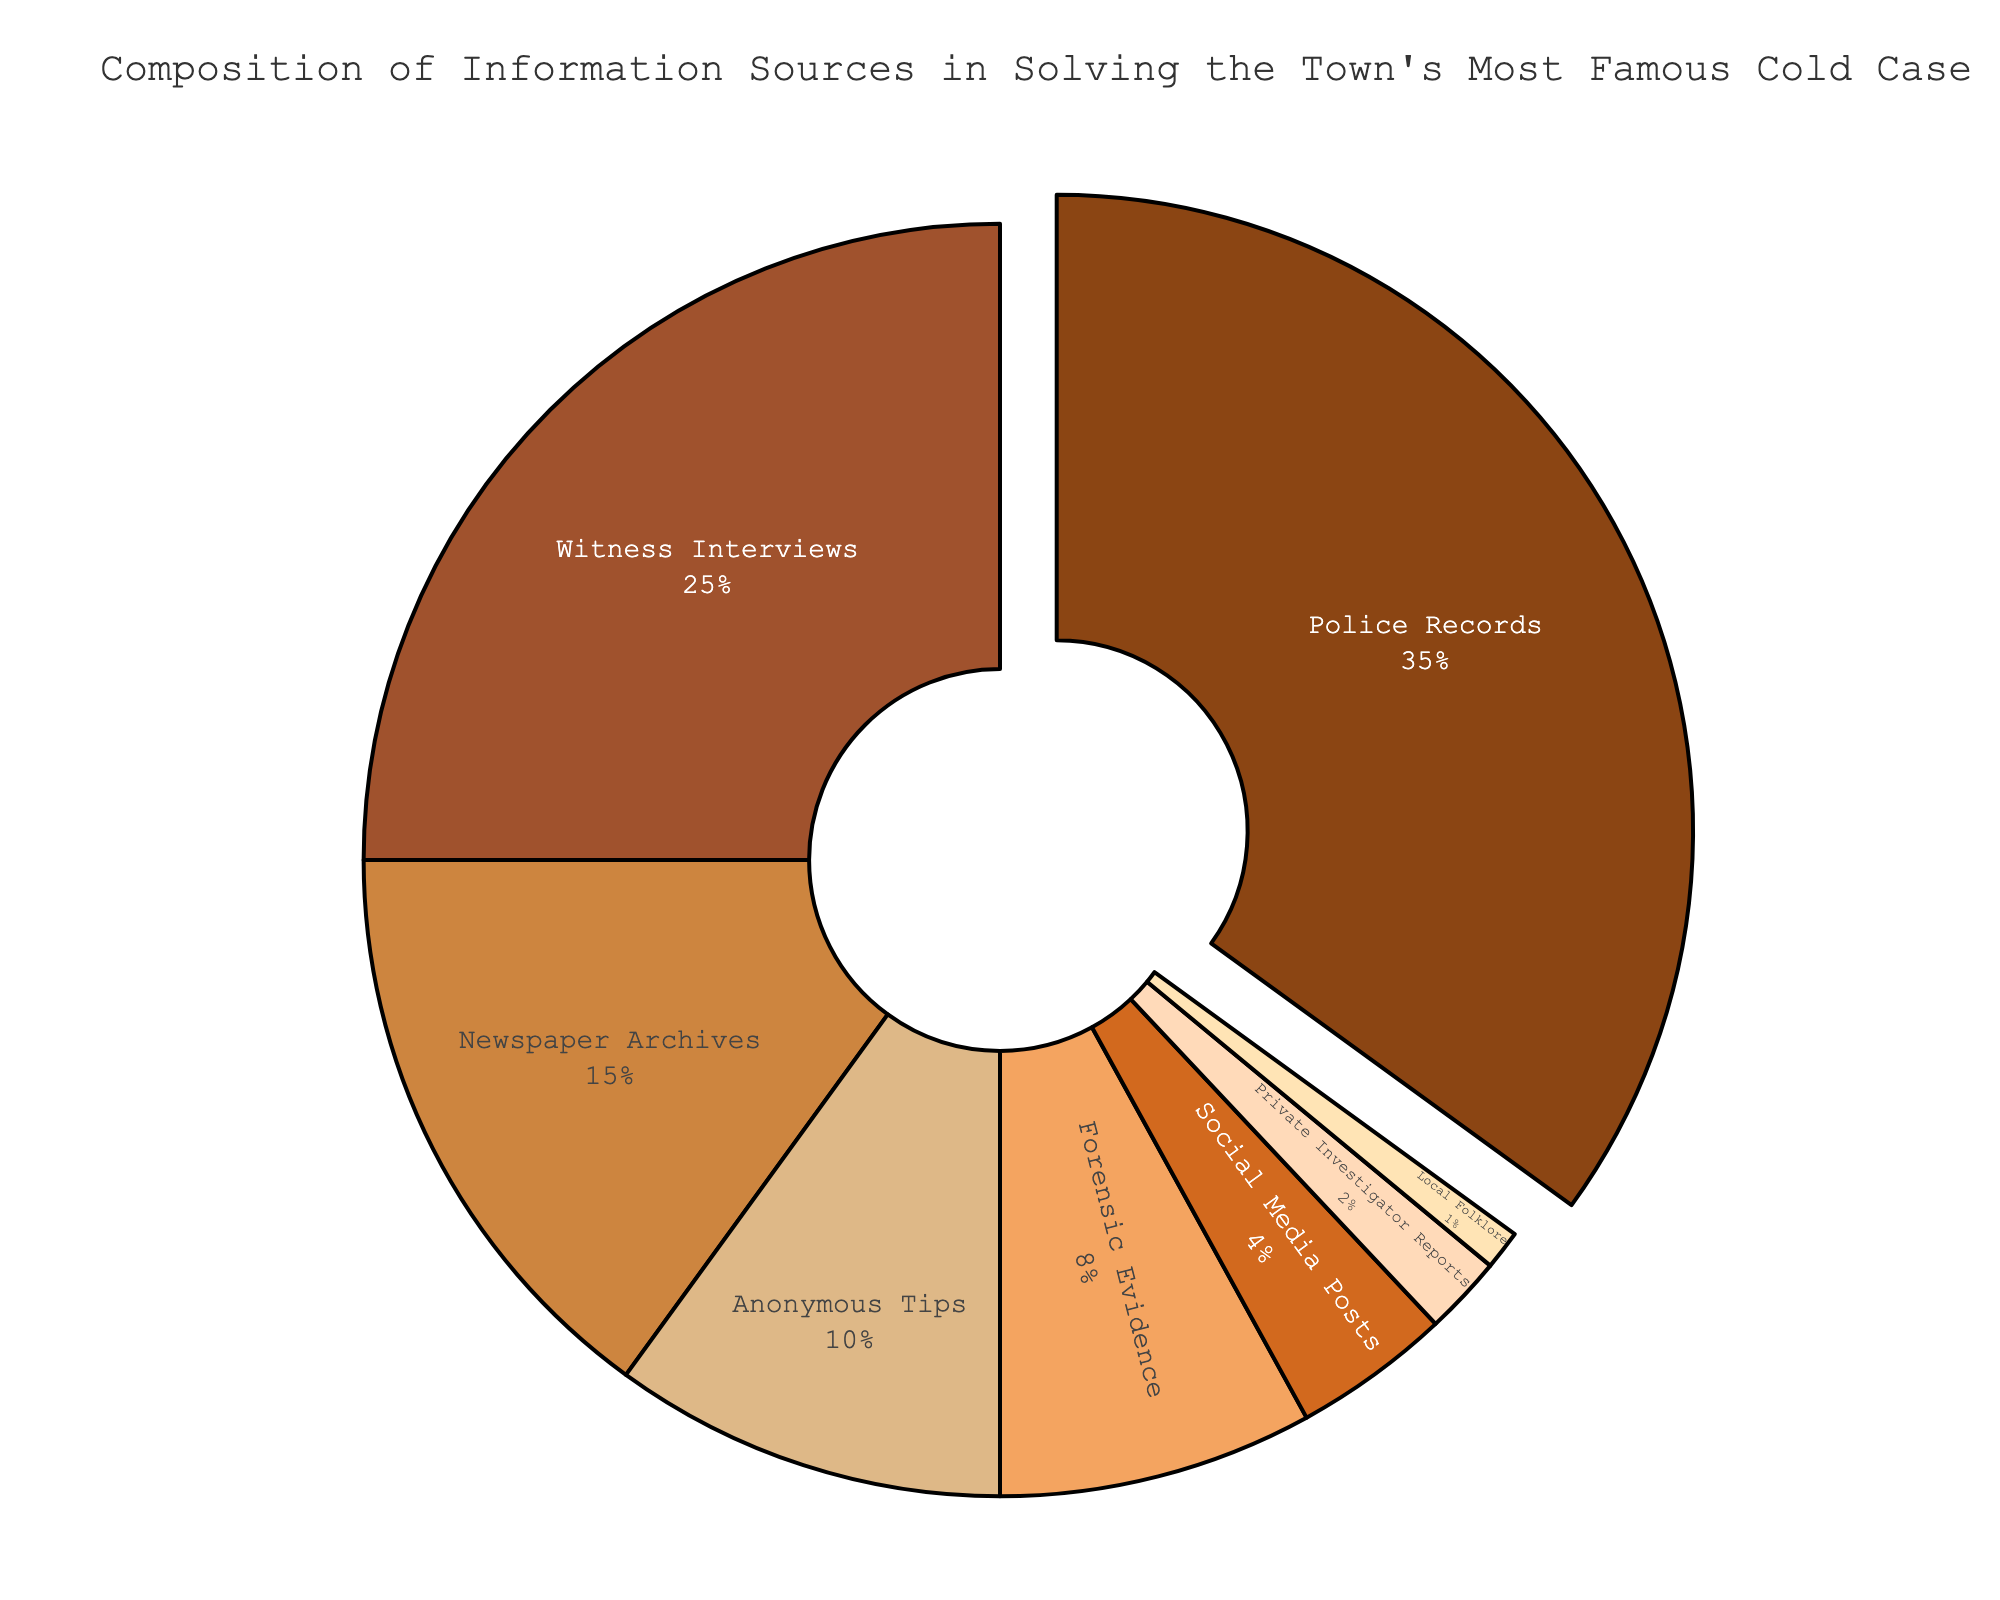What percentage of information sources came from witness interviews combined with anonymous tips? First, we find the percentage for witness interviews (25%) and anonymous tips (10%). Adding these together, 25% + 10% = 35%.
Answer: 35% Which category single-handedly provided more information, police records or newspaper archives? Compare the percentages for police records (35%) and newspaper archives (15%). Since 35% > 15%, police records provided more information.
Answer: Police records What is the smallest contributing information source? From the given data, local folklore contributes the smallest percentage at 1%.
Answer: Local folklore What is the difference in percentage between forensic evidence and private investigator reports? The percentage for forensic evidence is 8%, and for private investigator reports, it is 2%. The difference is 8% - 2% = 6%.
Answer: 6% Which category occupies a pie slice pulled outward in the figure? The figure has the category of police records pulled outward.
Answer: Police records How does the combined percentage of forensic evidence and social media posts compare to the percentage of newspaper archives? Forensic evidence is 8% and social media posts are 4%. Adding these together, 8% + 4% = 12%. The percentage for newspaper archives is 15%. Since 12% < 15%, the combination is lesser.
Answer: Lesser What is the combined percentage of the three categories with the smallest contributions? The three smallest contributing categories are local folklore (1%), private investigator reports (2%), and social media posts (4%). Adding these together, 1% + 2% + 4% = 7%.
Answer: 7% What's the difference between the largest and the second-largest contributing categories? The largest is police records with 35%, and the second-largest is witness interviews with 25%. The difference is 35% - 25% = 10%.
Answer: 10% Considering visual attributes, which slice's segment is colored darkest? The darkest color in the pie chart corresponds to police records.
Answer: Police records If we combined all the other categories except police records, will their total percentage be higher than that of police records alone? The total percentage for other categories (25 + 15 + 10 + 8 + 4 + 2 + 1) = 65%. Since 65% > 35%, the combined percentage of all other categories is higher than that of police records.
Answer: Yes 